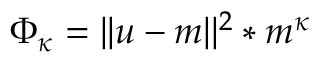Convert formula to latex. <formula><loc_0><loc_0><loc_500><loc_500>\Phi _ { \kappa } = | | u - m | | ^ { 2 } * m ^ { \kappa }</formula> 